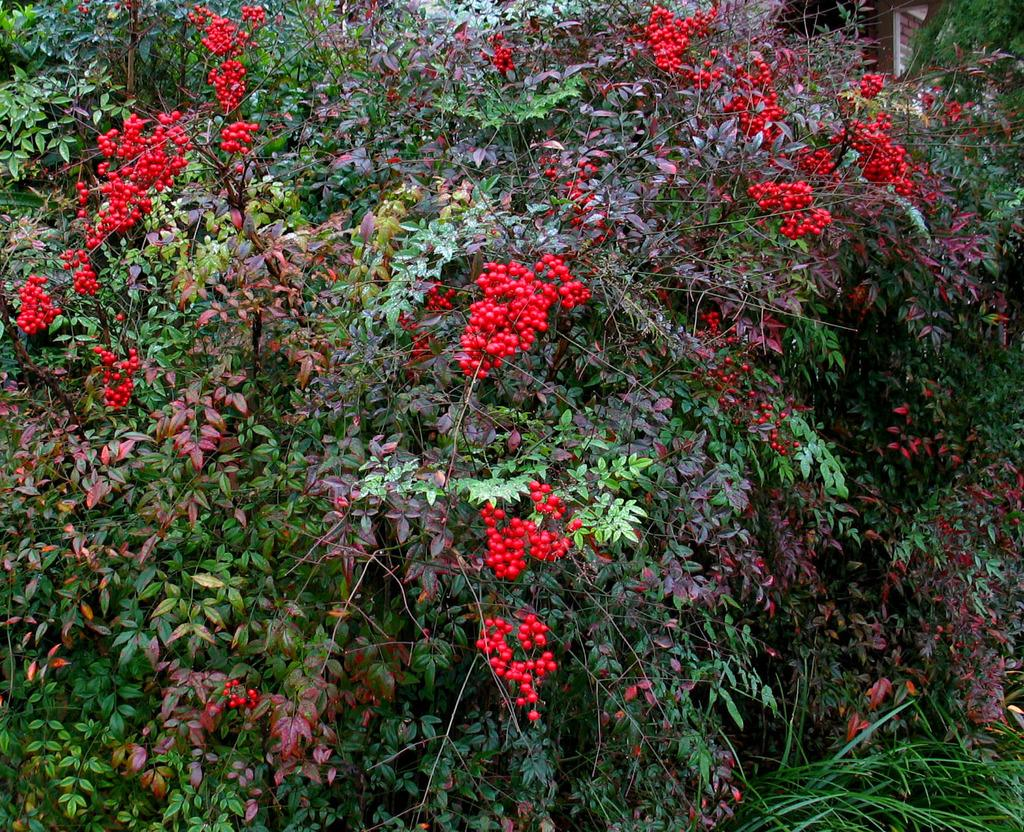What type of living organisms are present in the image? There are plants in the image. What specific parts of the plants can be seen? The plants have leaves, berries, and stems. How many feet are visible on the plants in the image? Plants do not have feet, so there are no feet visible on the plants in the image. 